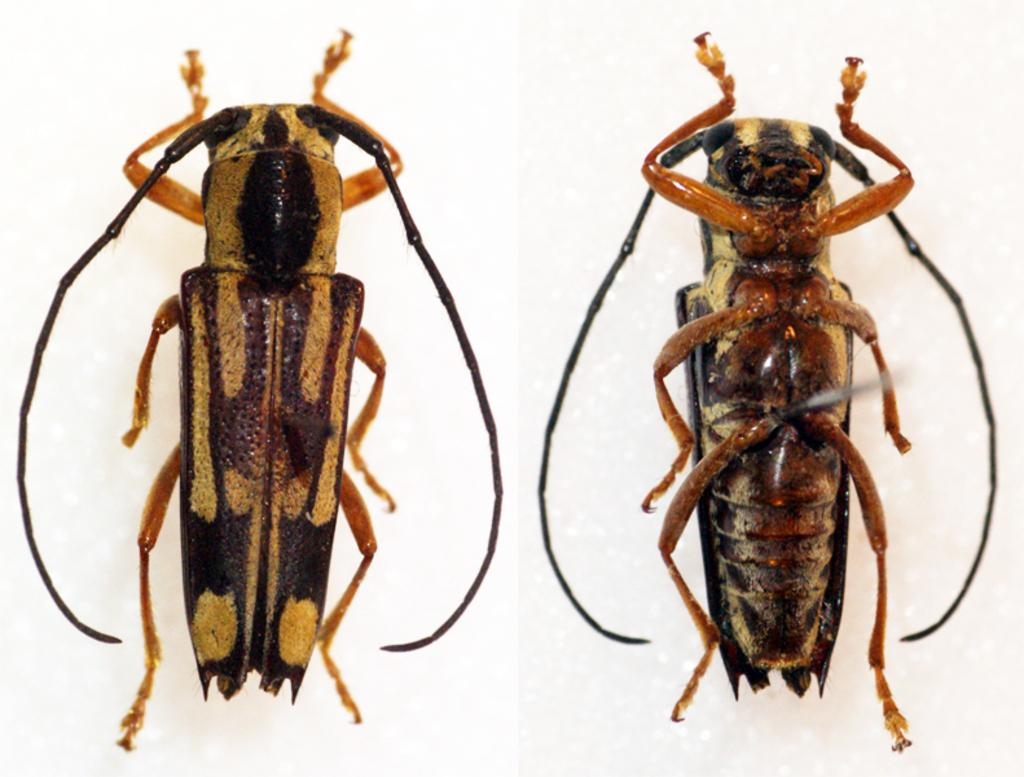How many insects are present in the image? There are two insects in the image. What can be seen in the background of the image? The background of the image is white. What type of police equipment can be seen in the image? There is no police equipment present in the image; it features two insects against a white background. Where is the lunchroom located in the image? There is no lunchroom present in the image; it features two insects against a white background. 